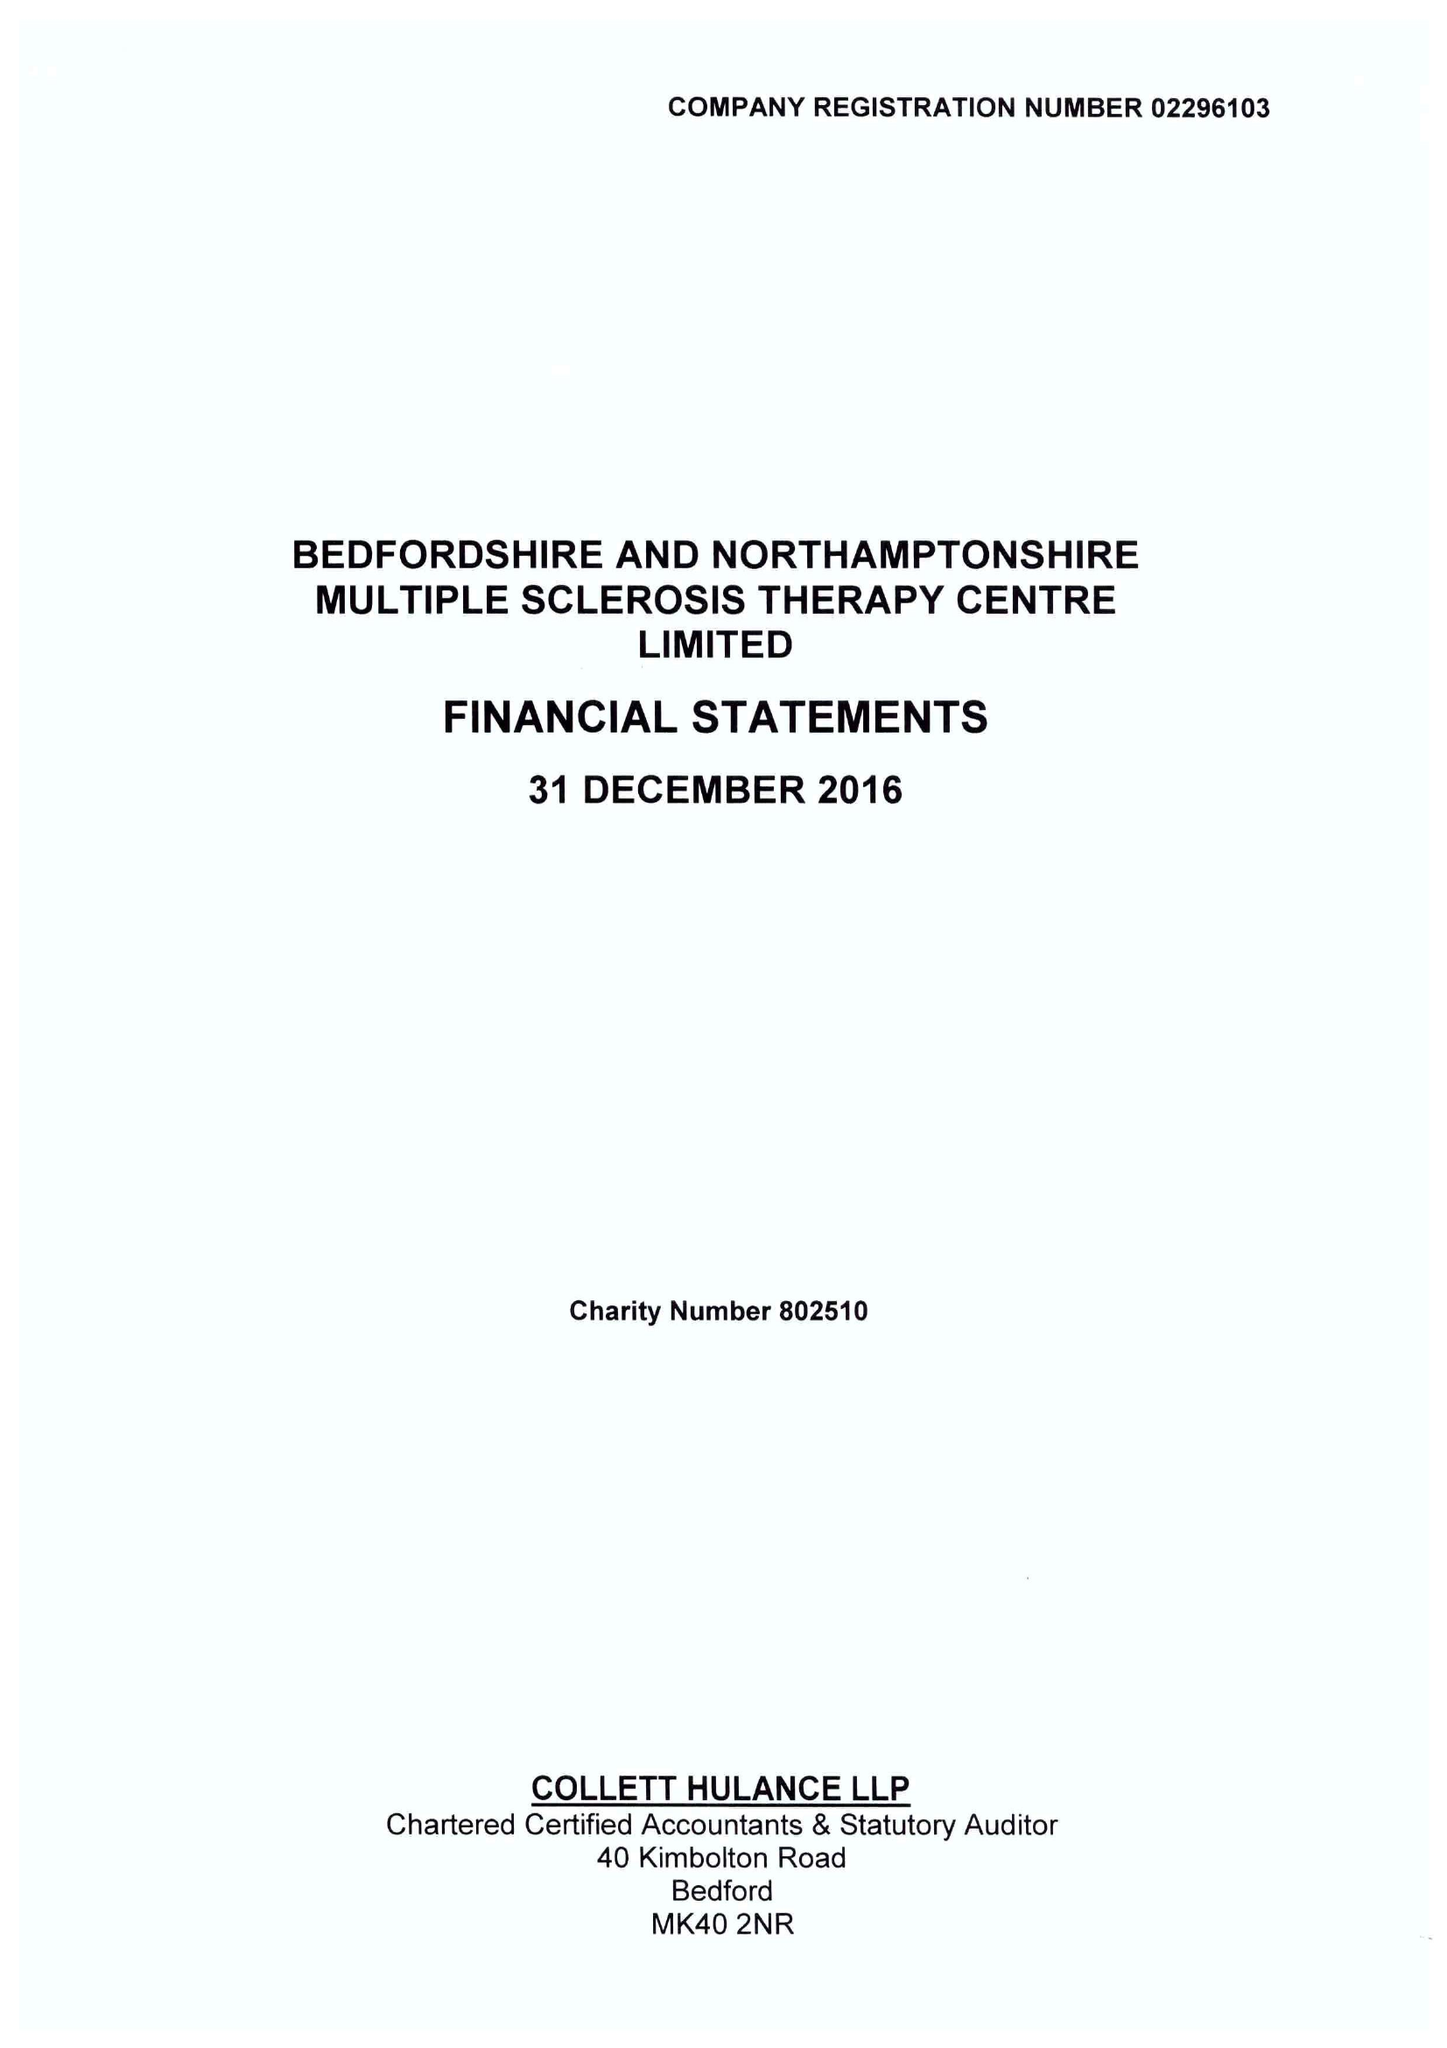What is the value for the address__postcode?
Answer the question using a single word or phrase. MK41 9RX 